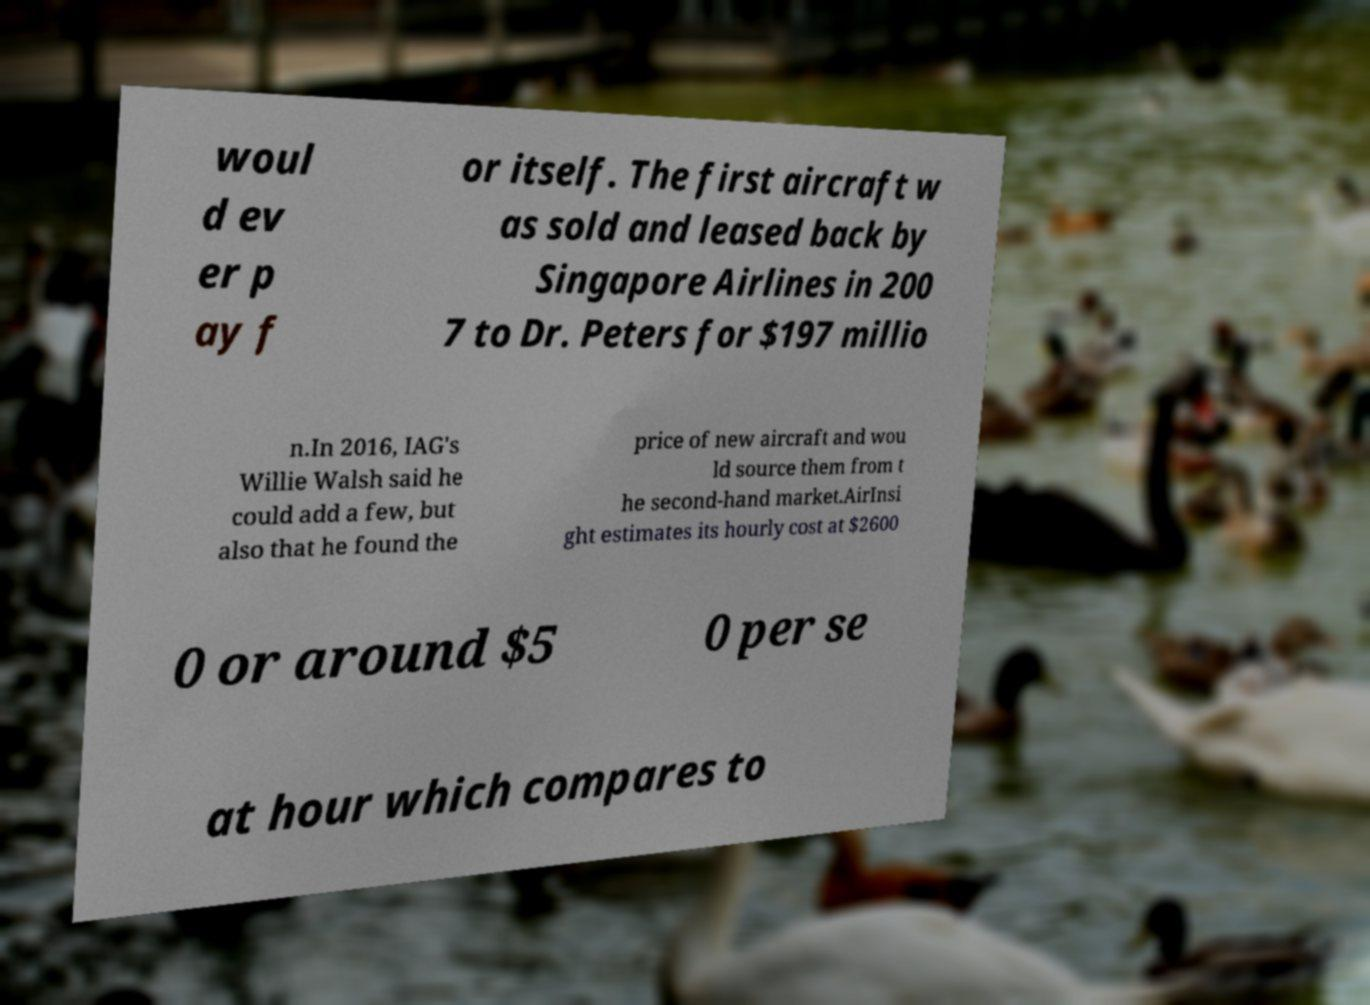Please read and relay the text visible in this image. What does it say? woul d ev er p ay f or itself. The first aircraft w as sold and leased back by Singapore Airlines in 200 7 to Dr. Peters for $197 millio n.In 2016, IAG's Willie Walsh said he could add a few, but also that he found the price of new aircraft and wou ld source them from t he second-hand market.AirInsi ght estimates its hourly cost at $2600 0 or around $5 0 per se at hour which compares to 